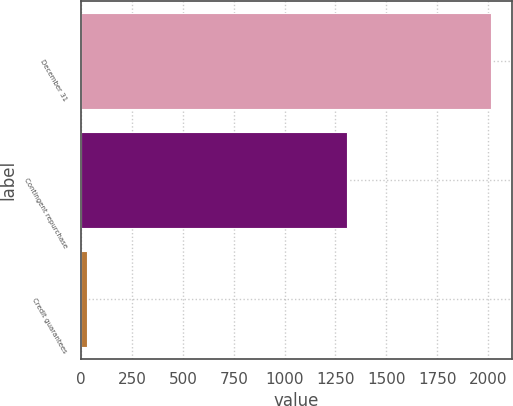Convert chart. <chart><loc_0><loc_0><loc_500><loc_500><bar_chart><fcel>December 31<fcel>Contingent repurchase<fcel>Credit guarantees<nl><fcel>2016<fcel>1306<fcel>29<nl></chart> 